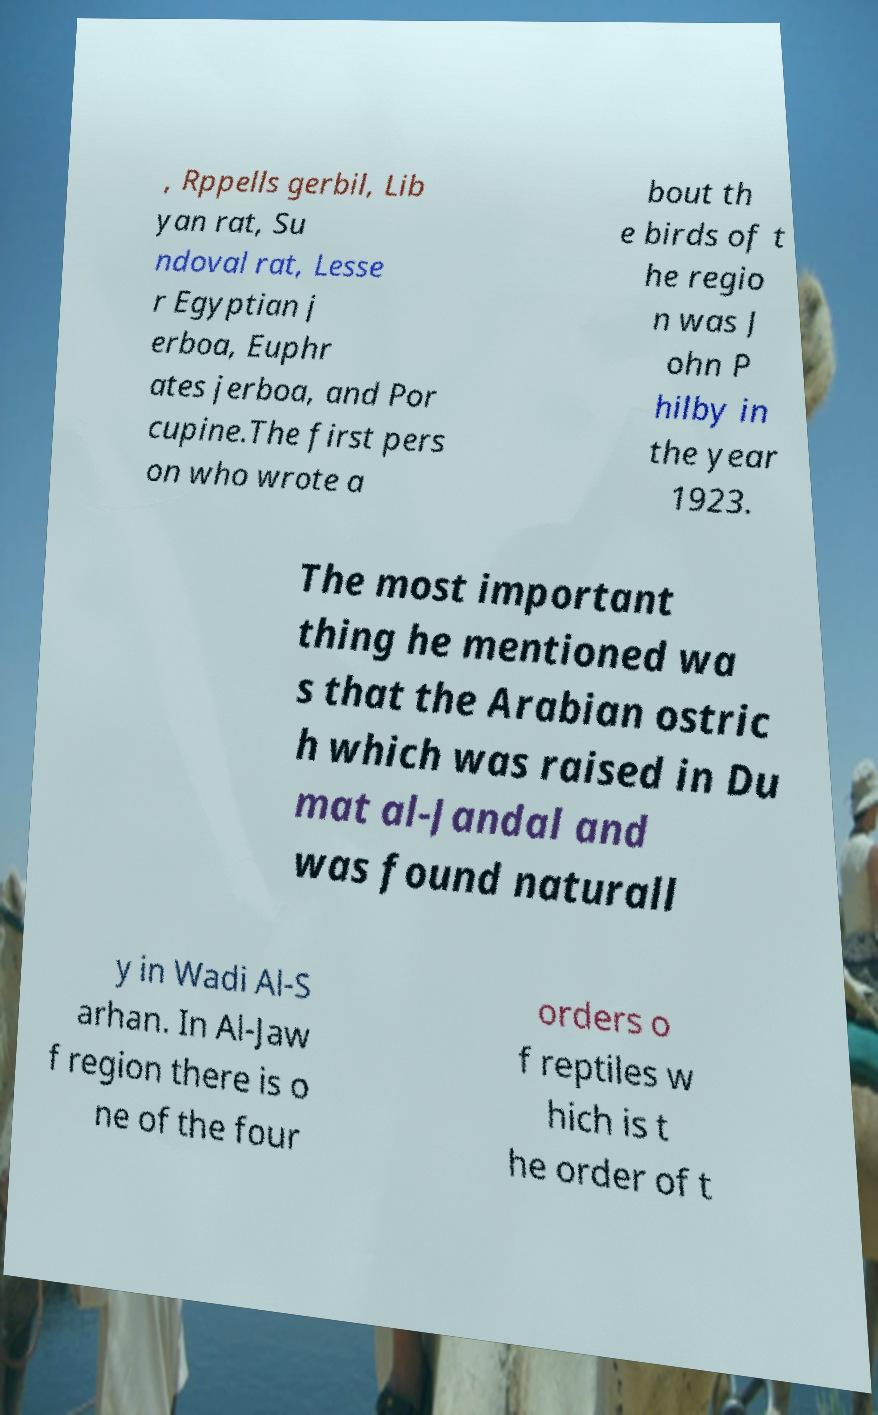Please identify and transcribe the text found in this image. , Rppells gerbil, Lib yan rat, Su ndoval rat, Lesse r Egyptian j erboa, Euphr ates jerboa, and Por cupine.The first pers on who wrote a bout th e birds of t he regio n was J ohn P hilby in the year 1923. The most important thing he mentioned wa s that the Arabian ostric h which was raised in Du mat al-Jandal and was found naturall y in Wadi Al-S arhan. In Al-Jaw f region there is o ne of the four orders o f reptiles w hich is t he order of t 